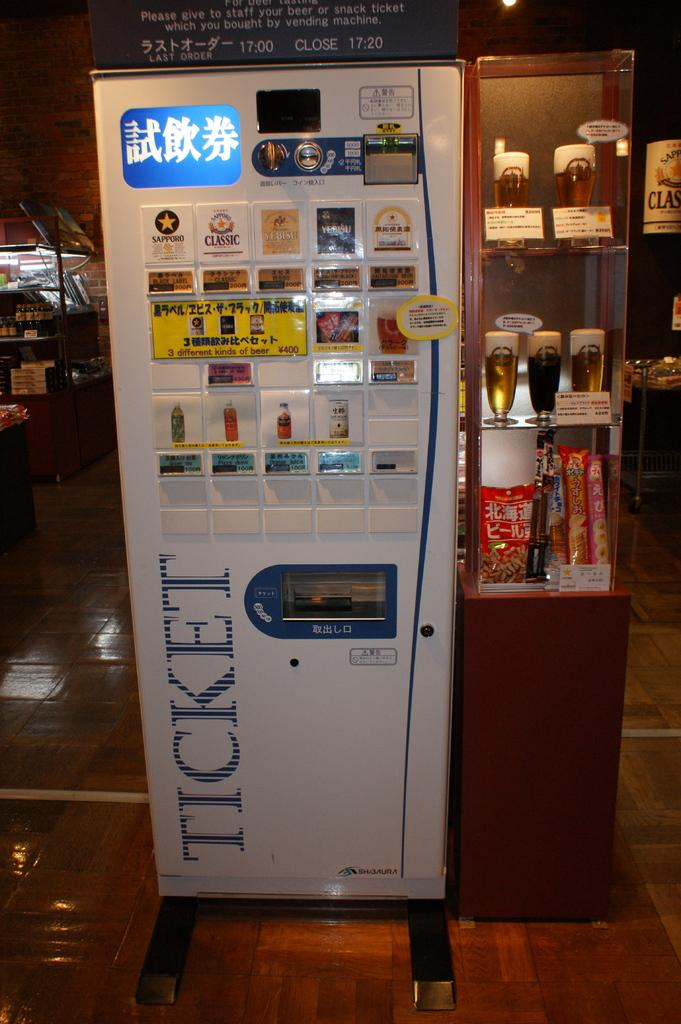<image>
Share a concise interpretation of the image provided. A ticket machine and samples of refreshments in a showcase sit in a movie theater lobby. 